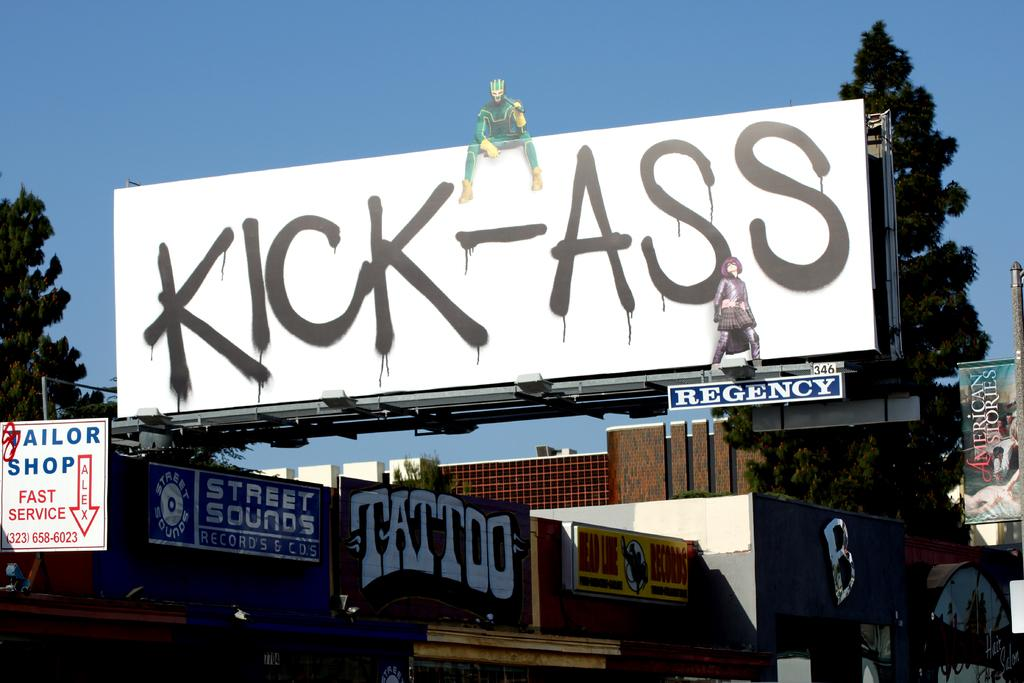<image>
Render a clear and concise summary of the photo. A very large white billboard with the words Kick-Ass on it. 